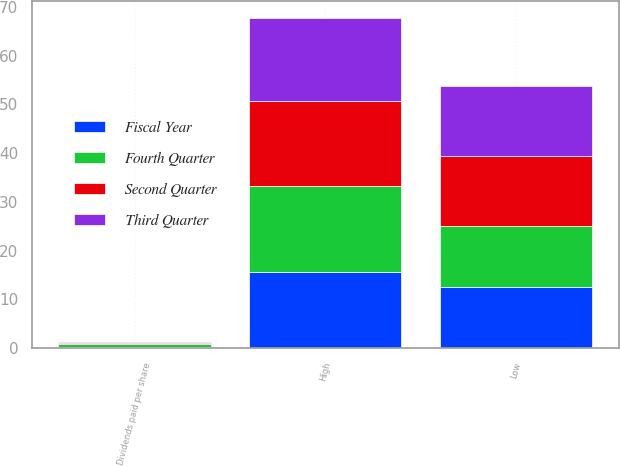Convert chart to OTSL. <chart><loc_0><loc_0><loc_500><loc_500><stacked_bar_chart><ecel><fcel>Dividends paid per share<fcel>High<fcel>Low<nl><fcel>Fourth Quarter<fcel>0.7<fcel>17.75<fcel>12.54<nl><fcel>Second Quarter<fcel>0.2<fcel>17.46<fcel>14.35<nl><fcel>Third Quarter<fcel>0.2<fcel>17.09<fcel>14.41<nl><fcel>Fiscal Year<fcel>0.15<fcel>15.52<fcel>12.54<nl></chart> 